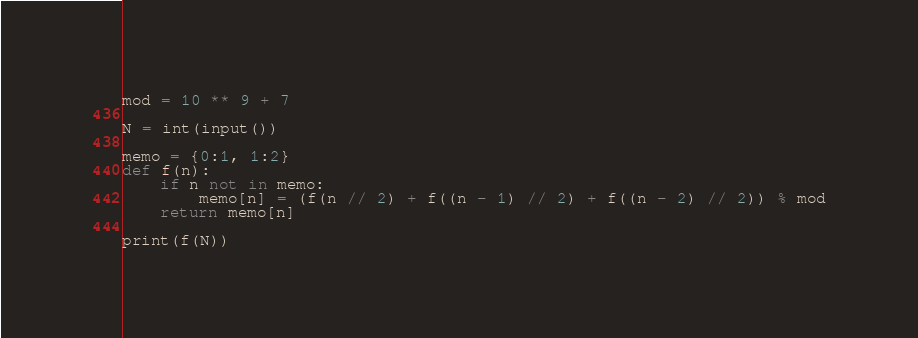Convert code to text. <code><loc_0><loc_0><loc_500><loc_500><_Python_>mod = 10 ** 9 + 7

N = int(input())

memo = {0:1, 1:2}
def f(n):
    if n not in memo:
        memo[n] = (f(n // 2) + f((n - 1) // 2) + f((n - 2) // 2)) % mod
    return memo[n]

print(f(N))</code> 